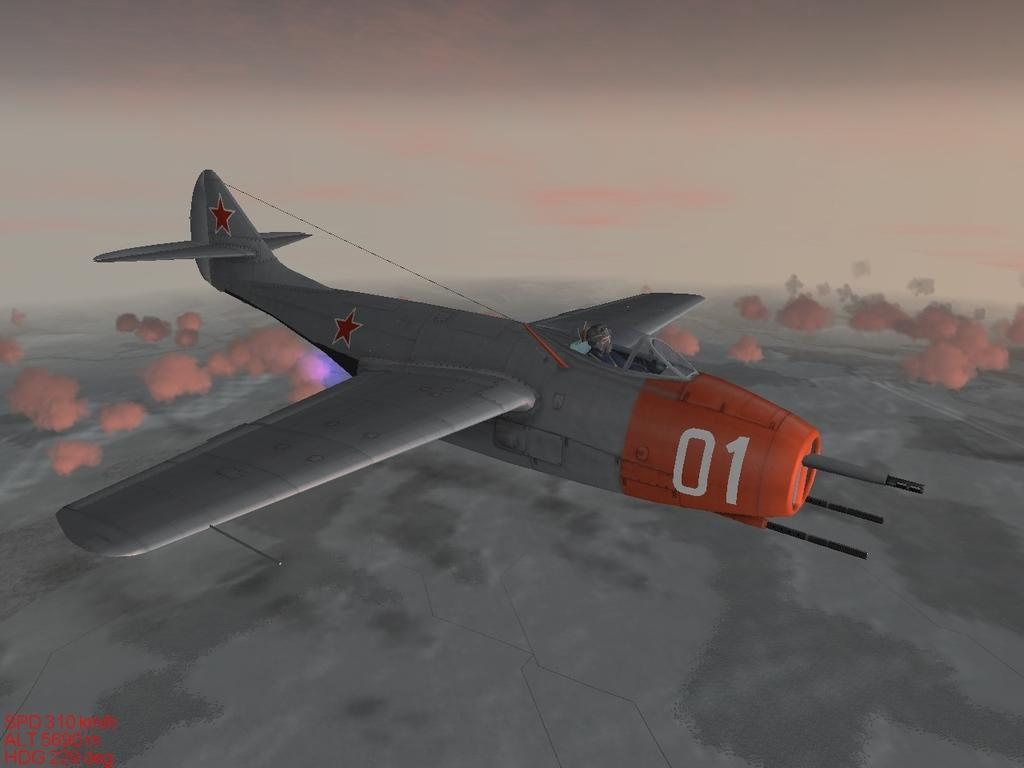What is the main subject of the image? The main subject of the image is an airplane. What is the airplane doing in the image? The airplane is flying in the air. What feature of the airplane is visible in the image? The airplane has wings. What is visible in the background of the image? The sky is visible in the image. What is the aftermath of the children's fiction in the image? There is no reference to children or fiction in the image; it features an airplane flying in the sky. 